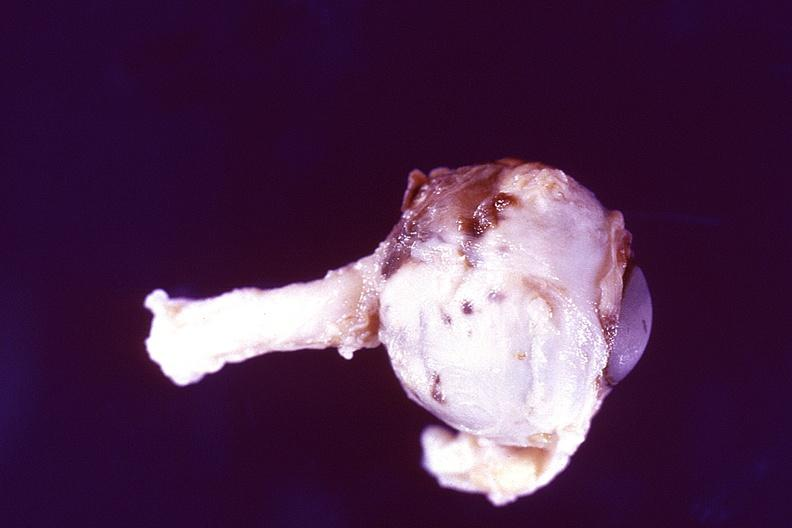does this image show disseminated intravascular coagulation dic?
Answer the question using a single word or phrase. Yes 